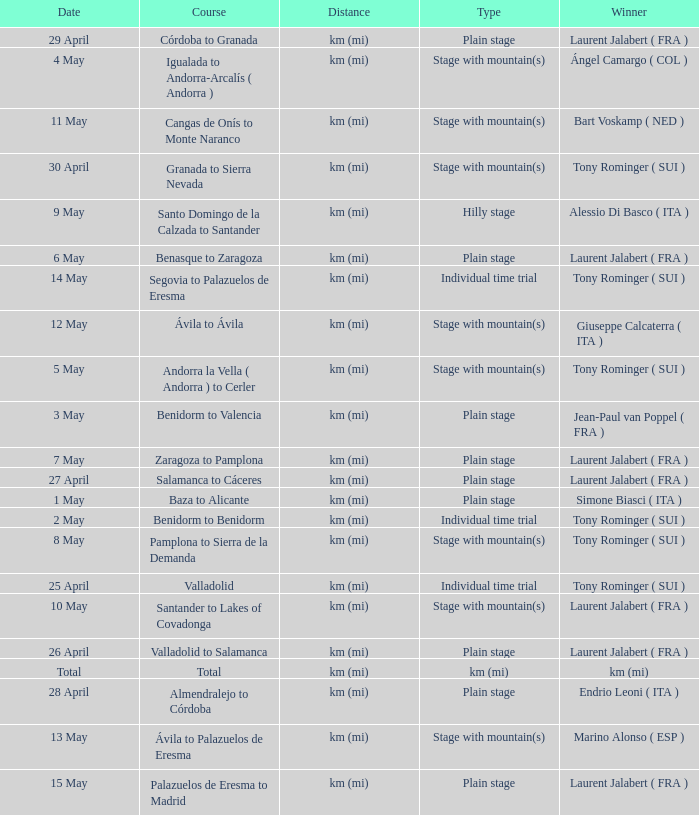Give me the full table as a dictionary. {'header': ['Date', 'Course', 'Distance', 'Type', 'Winner'], 'rows': [['29 April', 'Córdoba to Granada', 'km (mi)', 'Plain stage', 'Laurent Jalabert ( FRA )'], ['4 May', 'Igualada to Andorra-Arcalís ( Andorra )', 'km (mi)', 'Stage with mountain(s)', 'Ángel Camargo ( COL )'], ['11 May', 'Cangas de Onís to Monte Naranco', 'km (mi)', 'Stage with mountain(s)', 'Bart Voskamp ( NED )'], ['30 April', 'Granada to Sierra Nevada', 'km (mi)', 'Stage with mountain(s)', 'Tony Rominger ( SUI )'], ['9 May', 'Santo Domingo de la Calzada to Santander', 'km (mi)', 'Hilly stage', 'Alessio Di Basco ( ITA )'], ['6 May', 'Benasque to Zaragoza', 'km (mi)', 'Plain stage', 'Laurent Jalabert ( FRA )'], ['14 May', 'Segovia to Palazuelos de Eresma', 'km (mi)', 'Individual time trial', 'Tony Rominger ( SUI )'], ['12 May', 'Ávila to Ávila', 'km (mi)', 'Stage with mountain(s)', 'Giuseppe Calcaterra ( ITA )'], ['5 May', 'Andorra la Vella ( Andorra ) to Cerler', 'km (mi)', 'Stage with mountain(s)', 'Tony Rominger ( SUI )'], ['3 May', 'Benidorm to Valencia', 'km (mi)', 'Plain stage', 'Jean-Paul van Poppel ( FRA )'], ['7 May', 'Zaragoza to Pamplona', 'km (mi)', 'Plain stage', 'Laurent Jalabert ( FRA )'], ['27 April', 'Salamanca to Cáceres', 'km (mi)', 'Plain stage', 'Laurent Jalabert ( FRA )'], ['1 May', 'Baza to Alicante', 'km (mi)', 'Plain stage', 'Simone Biasci ( ITA )'], ['2 May', 'Benidorm to Benidorm', 'km (mi)', 'Individual time trial', 'Tony Rominger ( SUI )'], ['8 May', 'Pamplona to Sierra de la Demanda', 'km (mi)', 'Stage with mountain(s)', 'Tony Rominger ( SUI )'], ['25 April', 'Valladolid', 'km (mi)', 'Individual time trial', 'Tony Rominger ( SUI )'], ['10 May', 'Santander to Lakes of Covadonga', 'km (mi)', 'Stage with mountain(s)', 'Laurent Jalabert ( FRA )'], ['26 April', 'Valladolid to Salamanca', 'km (mi)', 'Plain stage', 'Laurent Jalabert ( FRA )'], ['Total', 'Total', 'km (mi)', 'km (mi)', 'km (mi)'], ['28 April', 'Almendralejo to Córdoba', 'km (mi)', 'Plain stage', 'Endrio Leoni ( ITA )'], ['13 May', 'Ávila to Palazuelos de Eresma', 'km (mi)', 'Stage with mountain(s)', 'Marino Alonso ( ESP )'], ['15 May', 'Palazuelos de Eresma to Madrid', 'km (mi)', 'Plain stage', 'Laurent Jalabert ( FRA )']]} What was the date with a winner of km (mi)? Total. 